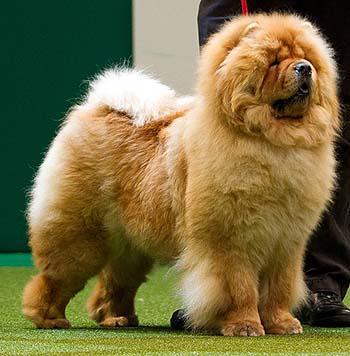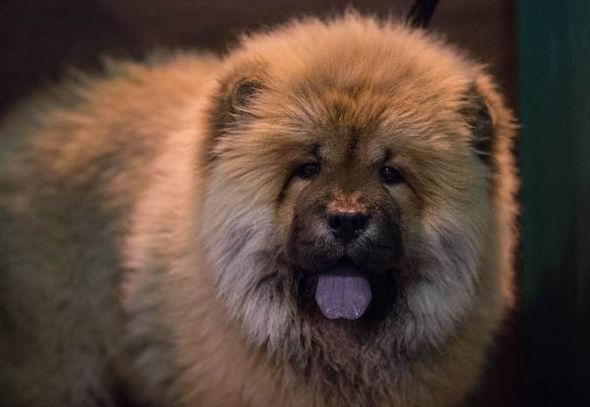The first image is the image on the left, the second image is the image on the right. For the images displayed, is the sentence "The dogs on the left are facing right." factually correct? Answer yes or no. Yes. 